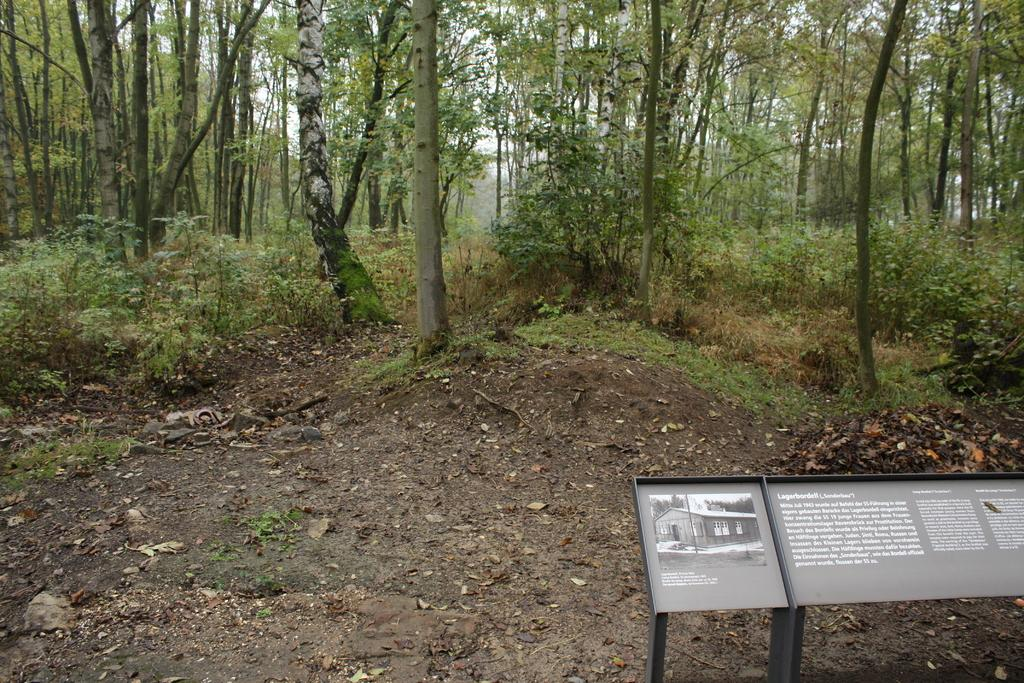What is on the board that is visible in the image? There is writing on the board in the image. How is the board positioned in the image? The board is attached to a stand. What can be seen in the background of the image? There are trees and plants in the background of the image. What type of pollution is visible in the image? There is no visible pollution in the image; it features a board with writing on it, a stand, trees, and plants in the background. 